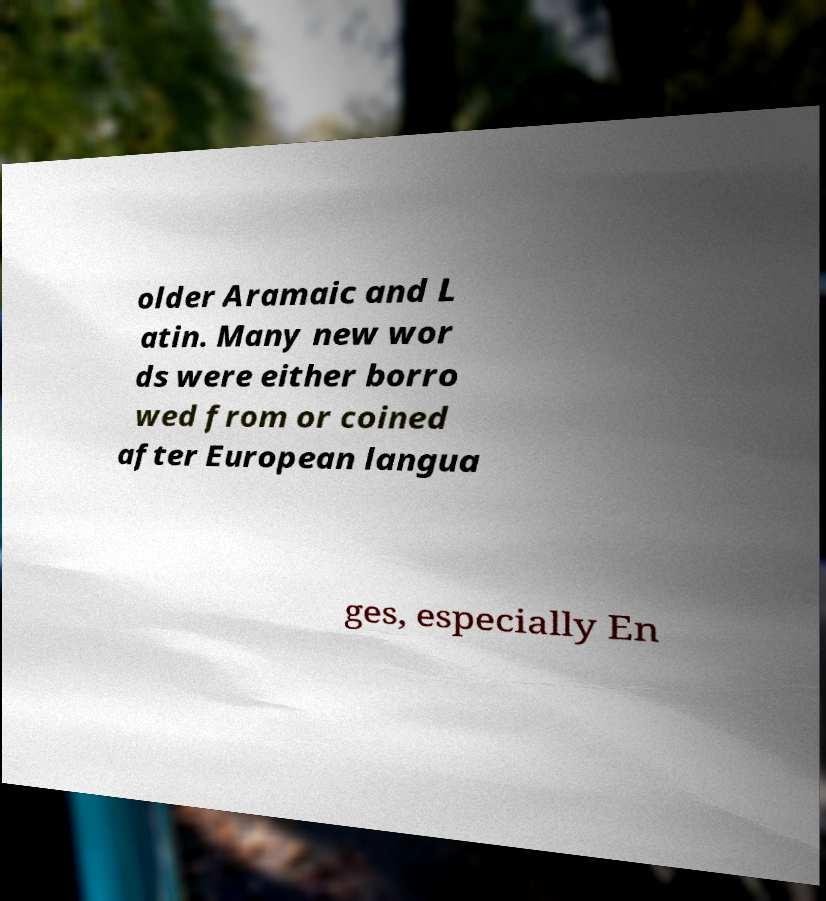Please identify and transcribe the text found in this image. older Aramaic and L atin. Many new wor ds were either borro wed from or coined after European langua ges, especially En 